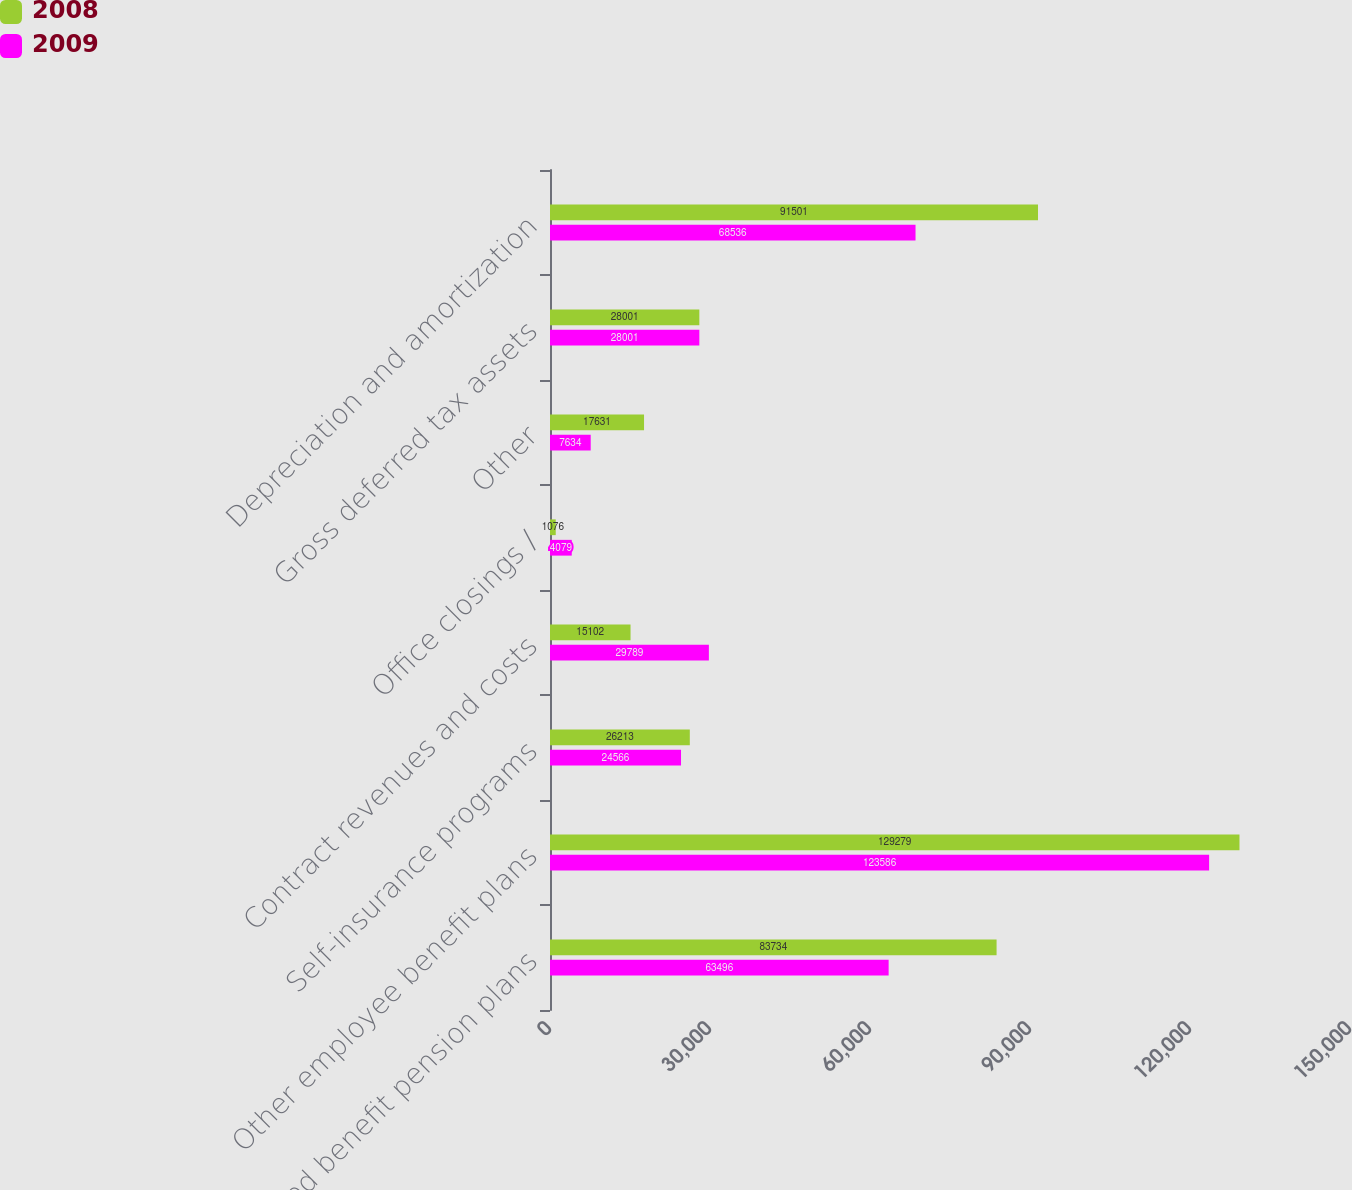Convert chart. <chart><loc_0><loc_0><loc_500><loc_500><stacked_bar_chart><ecel><fcel>Defined benefit pension plans<fcel>Other employee benefit plans<fcel>Self-insurance programs<fcel>Contract revenues and costs<fcel>Office closings /<fcel>Other<fcel>Gross deferred tax assets<fcel>Depreciation and amortization<nl><fcel>2008<fcel>83734<fcel>129279<fcel>26213<fcel>15102<fcel>1076<fcel>17631<fcel>28001<fcel>91501<nl><fcel>2009<fcel>63496<fcel>123586<fcel>24566<fcel>29789<fcel>4079<fcel>7634<fcel>28001<fcel>68536<nl></chart> 